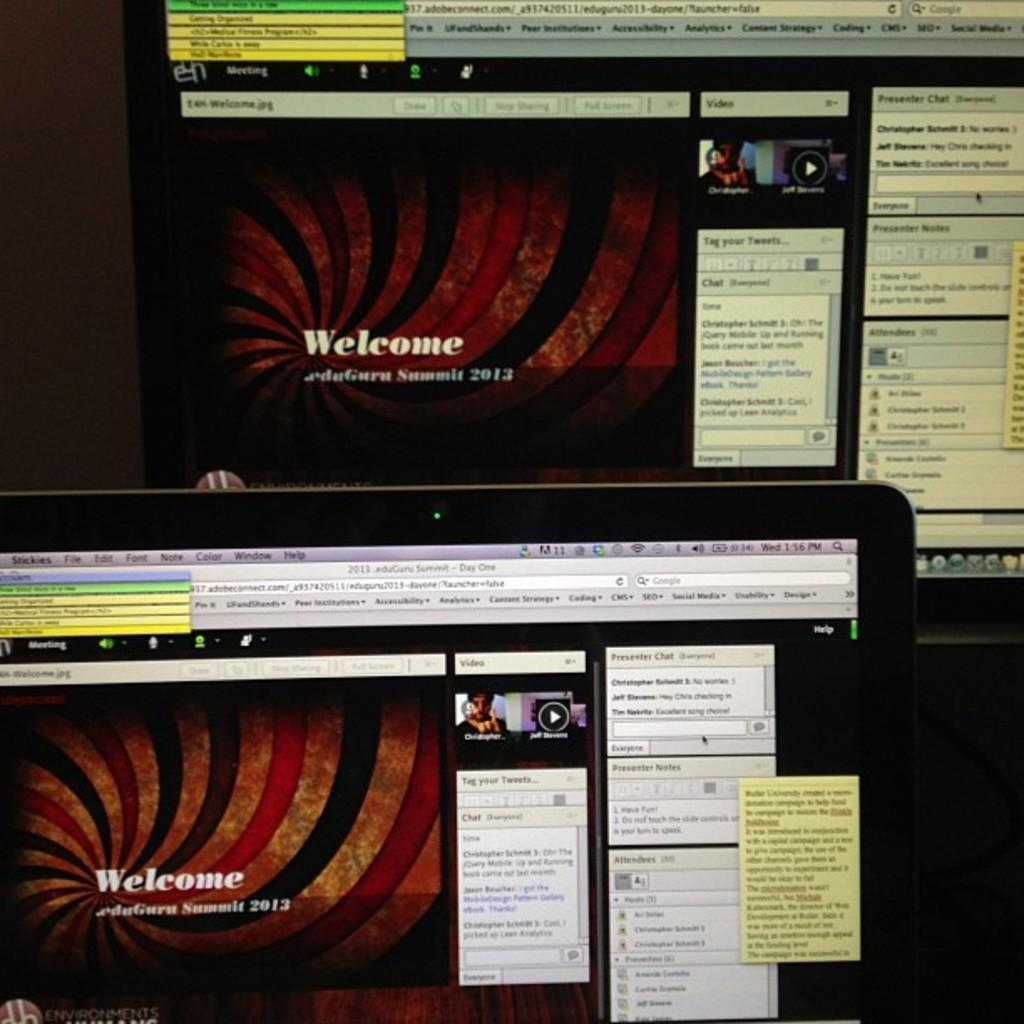<image>
Summarize the visual content of the image. A computer monitor with a Welcome page for edu.Guru Summit 2013 